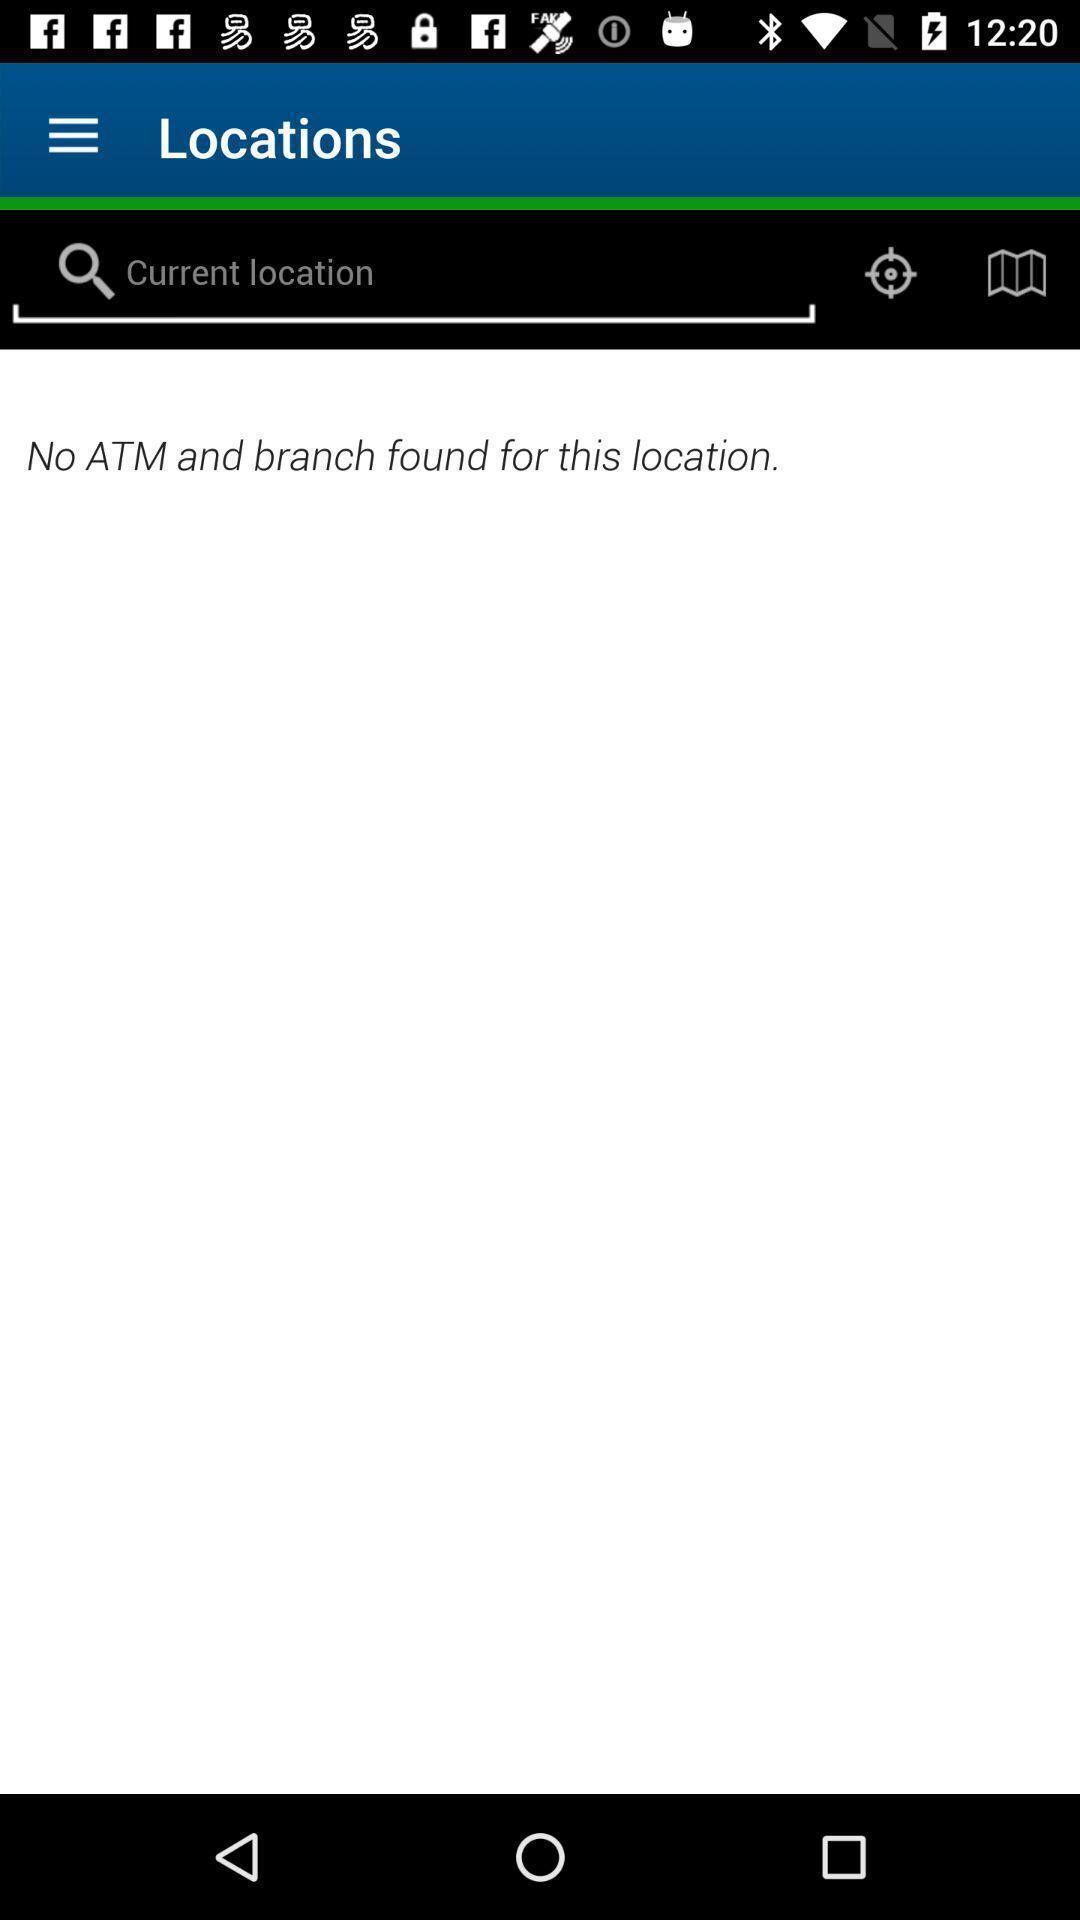Please provide a description for this image. Screen displaying a search bar in a navigation application. 